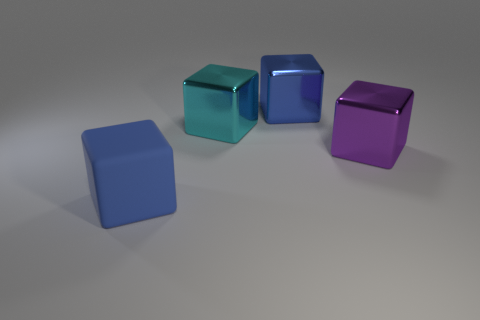Subtract all large blue matte cubes. How many cubes are left? 3 Subtract all cyan cubes. How many cubes are left? 3 Add 2 small green balls. How many objects exist? 6 Subtract all brown balls. How many purple cubes are left? 1 Subtract 0 red cylinders. How many objects are left? 4 Subtract 3 blocks. How many blocks are left? 1 Subtract all blue cubes. Subtract all yellow balls. How many cubes are left? 2 Subtract all small green cylinders. Subtract all blue matte cubes. How many objects are left? 3 Add 3 large purple metal blocks. How many large purple metal blocks are left? 4 Add 2 blue metallic cubes. How many blue metallic cubes exist? 3 